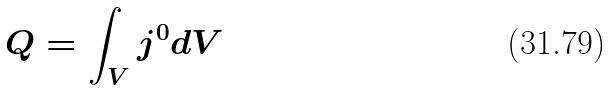Convert formula to latex. <formula><loc_0><loc_0><loc_500><loc_500>Q = \int _ { V } j ^ { 0 } d V</formula> 